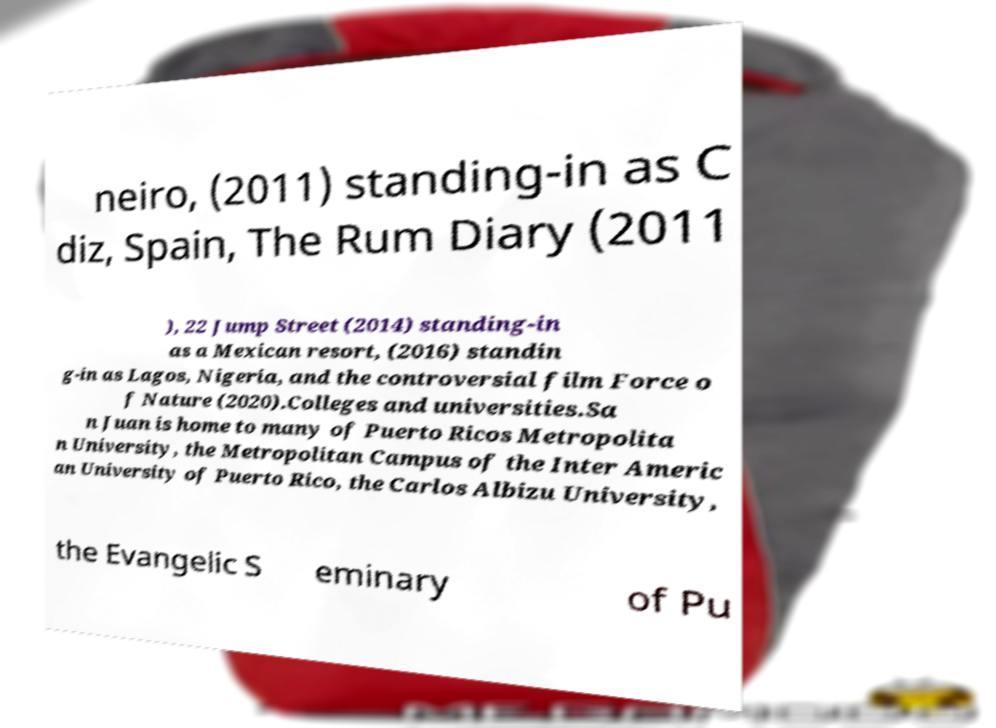For documentation purposes, I need the text within this image transcribed. Could you provide that? neiro, (2011) standing-in as C diz, Spain, The Rum Diary (2011 ), 22 Jump Street (2014) standing-in as a Mexican resort, (2016) standin g-in as Lagos, Nigeria, and the controversial film Force o f Nature (2020).Colleges and universities.Sa n Juan is home to many of Puerto Ricos Metropolita n University, the Metropolitan Campus of the Inter Americ an University of Puerto Rico, the Carlos Albizu University, the Evangelic S eminary of Pu 